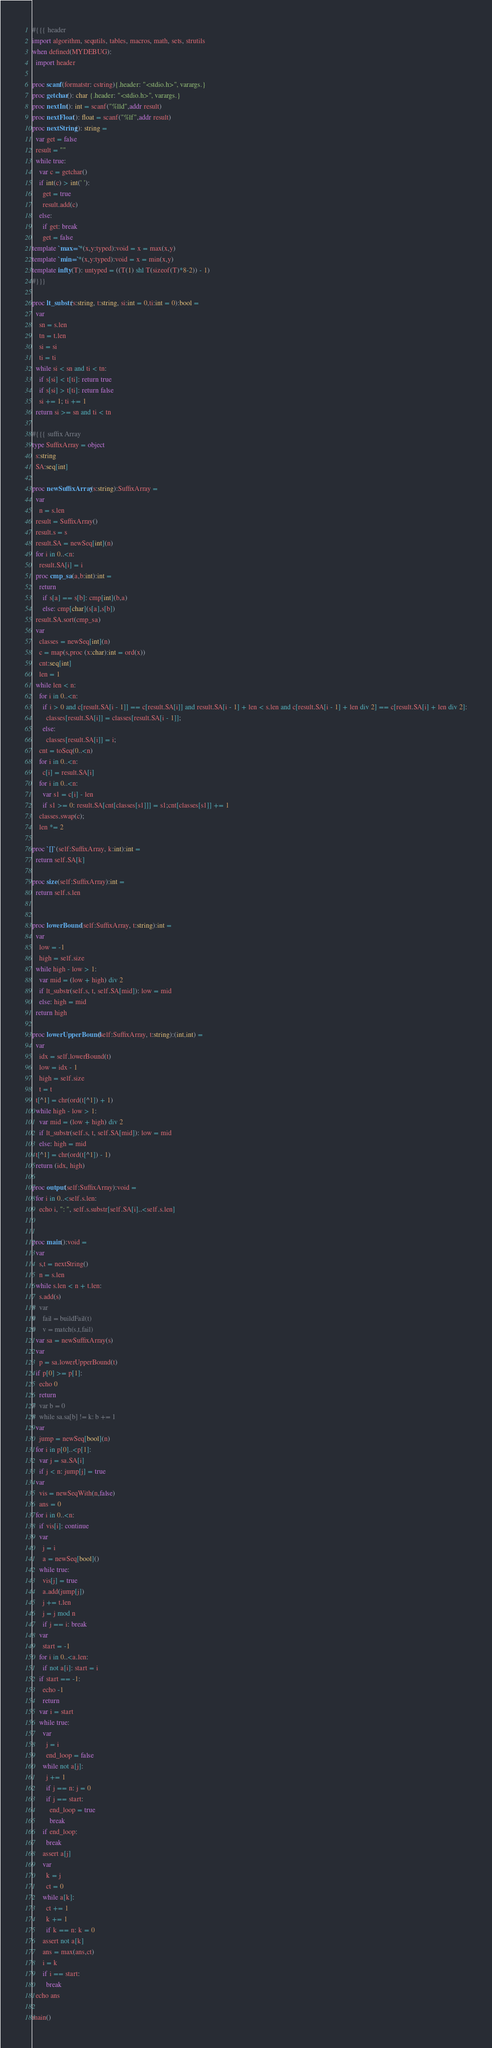<code> <loc_0><loc_0><loc_500><loc_500><_Nim_>#{{{ header
import algorithm, sequtils, tables, macros, math, sets, strutils
when defined(MYDEBUG):
  import header

proc scanf(formatstr: cstring){.header: "<stdio.h>", varargs.}
proc getchar(): char {.header: "<stdio.h>", varargs.}
proc nextInt(): int = scanf("%lld",addr result)
proc nextFloat(): float = scanf("%lf",addr result)
proc nextString(): string =
  var get = false
  result = ""
  while true:
    var c = getchar()
    if int(c) > int(' '):
      get = true
      result.add(c)
    else:
      if get: break
      get = false
template `max=`*(x,y:typed):void = x = max(x,y)
template `min=`*(x,y:typed):void = x = min(x,y)
template infty(T): untyped = ((T(1) shl T(sizeof(T)*8-2)) - 1)
#}}}

proc lt_substr(s:string, t:string, si:int = 0,ti:int = 0):bool =
  var
    sn = s.len
    tn = t.len
    si = si
    ti = ti
  while si < sn and ti < tn:
    if s[si] < t[ti]: return true
    if s[si] > t[ti]: return false
    si += 1; ti += 1
  return si >= sn and ti < tn

#{{{ suffix Array
type SuffixArray = object
  s:string
  SA:seq[int]

proc newSuffixArray(s:string):SuffixArray = 
  var
    n = s.len
  result = SuffixArray()
  result.s = s
  result.SA = newSeq[int](n)
  for i in 0..<n:
    result.SA[i] = i
  proc cmp_sa(a,b:int):int =
    return
      if s[a] == s[b]: cmp[int](b,a)
      else: cmp[char](s[a],s[b])
  result.SA.sort(cmp_sa)
  var
    classes = newSeq[int](n)
    c = map(s,proc (x:char):int = ord(x))
    cnt:seq[int]
    len = 1
  while len < n:
    for i in 0..<n:
      if i > 0 and c[result.SA[i - 1]] == c[result.SA[i]] and result.SA[i - 1] + len < s.len and c[result.SA[i - 1] + len div 2] == c[result.SA[i] + len div 2]:
        classes[result.SA[i]] = classes[result.SA[i - 1]];
      else:
        classes[result.SA[i]] = i;
    cnt = toSeq(0..<n)
    for i in 0..<n:
      c[i] = result.SA[i]
    for i in 0..<n:
      var s1 = c[i] - len
      if s1 >= 0: result.SA[cnt[classes[s1]]] = s1;cnt[classes[s1]] += 1
    classes.swap(c);
    len *= 2

proc `[]`(self:SuffixArray, k:int):int =
  return self.SA[k]

proc size(self:SuffixArray):int =
  return self.s.len


proc lowerBound(self:SuffixArray, t:string):int =
  var
    low = -1
    high = self.size
  while high - low > 1:
    var mid = (low + high) div 2
    if lt_substr(self.s, t, self.SA[mid]): low = mid
    else: high = mid
  return high

proc lowerUpperBound(self:SuffixArray, t:string):(int,int) =
  var
    idx = self.lowerBound(t)
    low = idx - 1
    high = self.size
    t = t
  t[^1] = chr(ord(t[^1]) + 1)
  while high - low > 1:
    var mid = (low + high) div 2
    if lt_substr(self.s, t, self.SA[mid]): low = mid
    else: high = mid
  t[^1] = chr(ord(t[^1]) - 1)
  return (idx, high)

proc output(self:SuffixArray):void =
  for i in 0..<self.s.len:
    echo i, ": ", self.s.substr[self.SA[i]..<self.s.len]


proc main():void =
  var
    s,t = nextString()
    n = s.len
  while s.len < n + t.len:
    s.add(s)
#  var
#    fail = buildFail(t)
#    v = match(s,t,fail)
  var sa = newSuffixArray(s)
  var
    p = sa.lowerUpperBound(t)
  if p[0] >= p[1]:
    echo 0
    return
#  var b = 0
#  while sa.sa[b] != k: b += 1
  var
    jump = newSeq[bool](n)
  for i in p[0]..<p[1]:
    var j = sa.SA[i]
    if j < n: jump[j] = true
  var
    vis = newSeqWith(n,false)
    ans = 0
  for i in 0..<n:
    if vis[i]: continue
    var
      j = i
      a = newSeq[bool]()
    while true:
      vis[j] = true
      a.add(jump[j])
      j += t.len
      j = j mod n
      if j == i: break
    var
      start = -1
    for i in 0..<a.len:
      if not a[i]: start = i
    if start == -1:
      echo -1
      return
    var i = start
    while true:
      var
        j = i
        end_loop = false
      while not a[j]:
        j += 1
        if j == n: j = 0
        if j == start:
          end_loop = true
          break
      if end_loop:
        break
      assert a[j]
      var
        k = j
        ct = 0
      while a[k]:
        ct += 1
        k += 1
        if k == n: k = 0
      assert not a[k]
      ans = max(ans,ct)
      i = k
      if i == start:
        break
  echo ans 

main()

</code> 